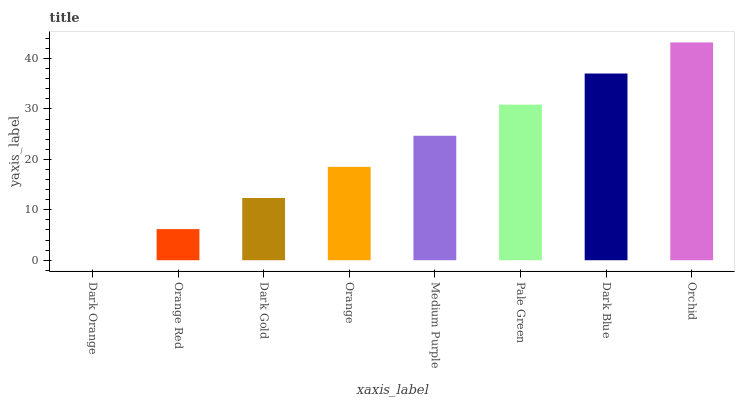Is Dark Orange the minimum?
Answer yes or no. Yes. Is Orchid the maximum?
Answer yes or no. Yes. Is Orange Red the minimum?
Answer yes or no. No. Is Orange Red the maximum?
Answer yes or no. No. Is Orange Red greater than Dark Orange?
Answer yes or no. Yes. Is Dark Orange less than Orange Red?
Answer yes or no. Yes. Is Dark Orange greater than Orange Red?
Answer yes or no. No. Is Orange Red less than Dark Orange?
Answer yes or no. No. Is Medium Purple the high median?
Answer yes or no. Yes. Is Orange the low median?
Answer yes or no. Yes. Is Orange Red the high median?
Answer yes or no. No. Is Orange Red the low median?
Answer yes or no. No. 